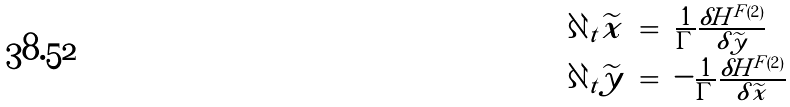<formula> <loc_0><loc_0><loc_500><loc_500>\begin{array} { c c l } \partial _ { t } \widetilde { x } & = & \frac { 1 } { \Gamma } \frac { \delta H ^ { F \left ( 2 \right ) } } { \delta \widetilde { y } } \\ \partial _ { t } \widetilde { y } & = & - \frac { 1 } { \Gamma } \frac { \delta H ^ { F \left ( 2 \right ) } } { \delta \widetilde { x } } \end{array}</formula> 